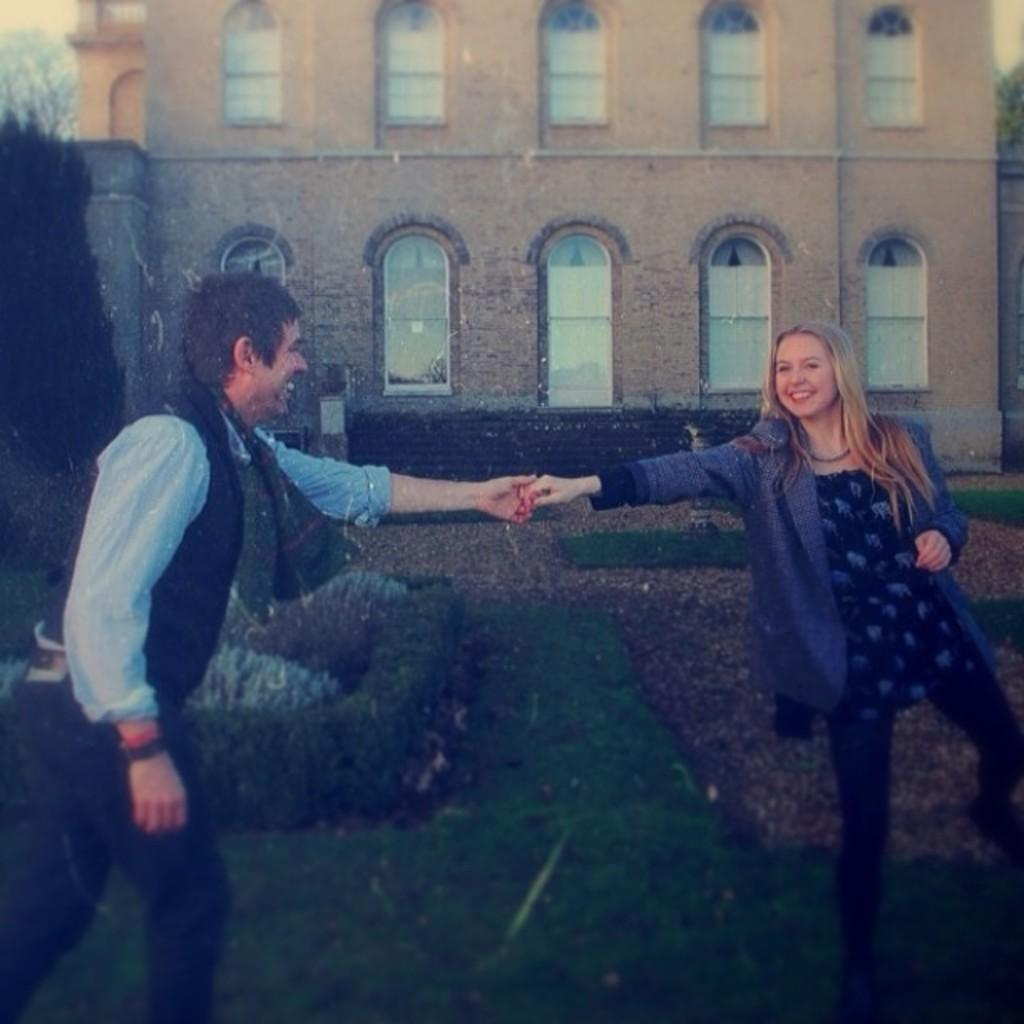Who is present in the image? There is a couple in the image. What are they doing in the image? The couple is standing on a greenery ground and holding hands. What can be seen in the background of the image? There is a building and trees in the background of the image. How many ladybugs can be seen on the couple's hands in the image? There are no ladybugs present on the couple's hands in the image. What is the growth rate of the trees in the background of the image? The growth rate of the trees cannot be determined from the image alone. 